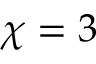<formula> <loc_0><loc_0><loc_500><loc_500>\chi = 3</formula> 